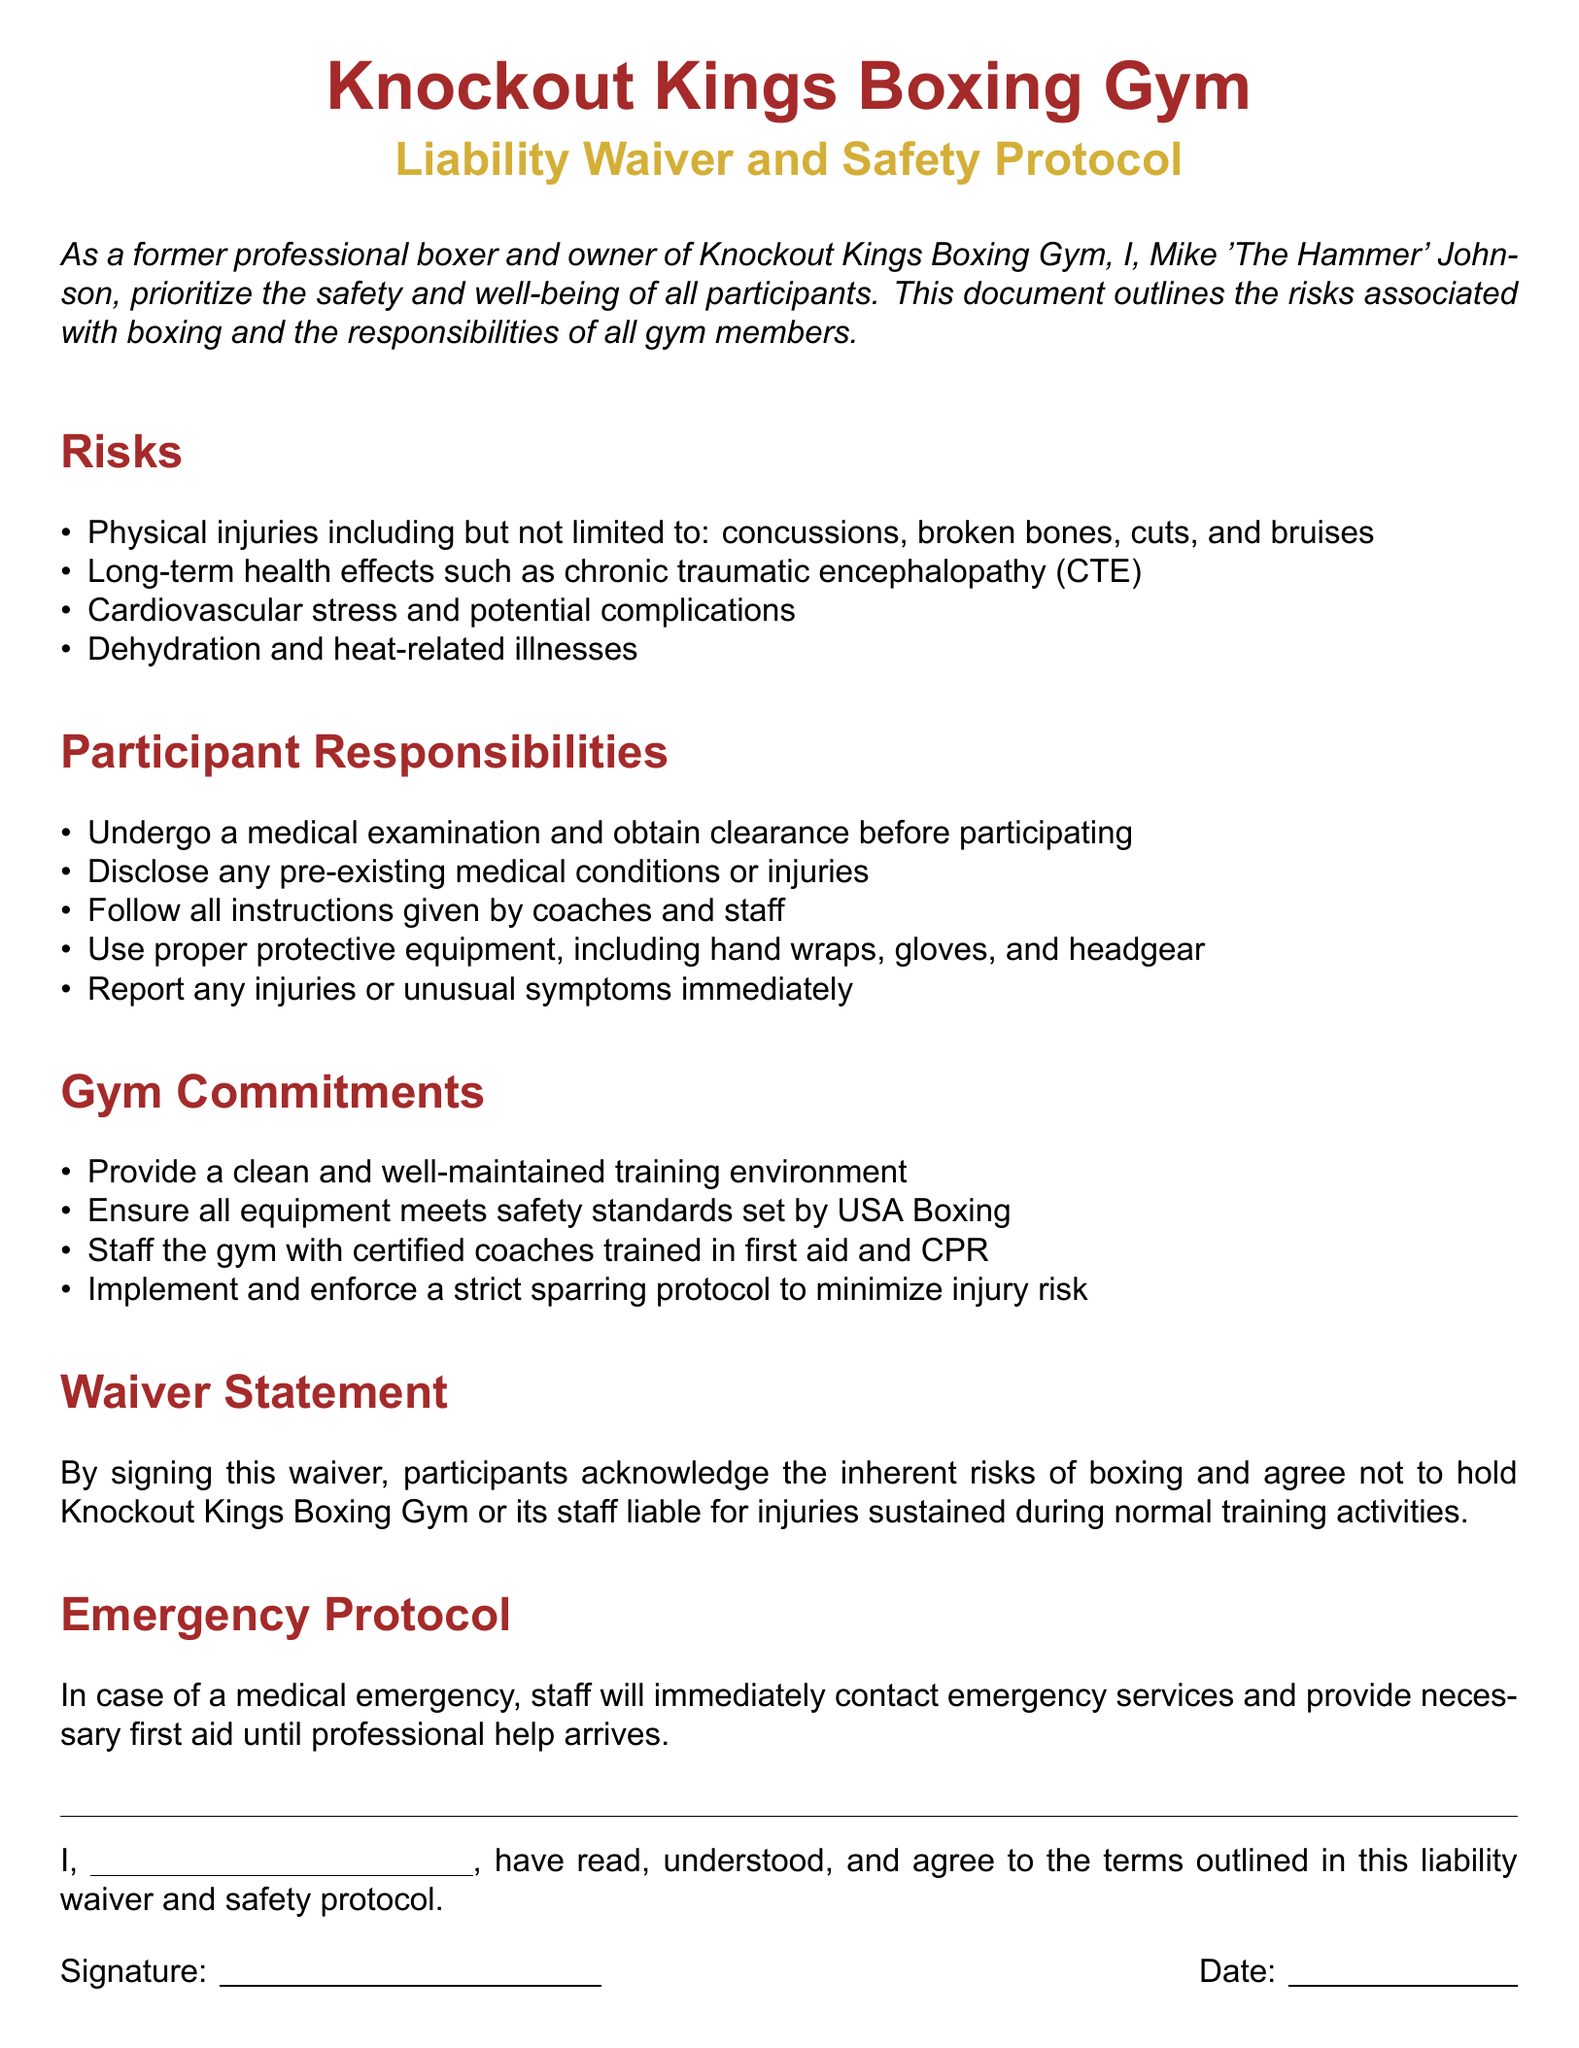What is the name of the gym? The name of the gym is stated prominently at the top of the document.
Answer: Knockout Kings Boxing Gym Who is the owner of the gym? The owner is mentioned in the introductory section of the document.
Answer: Mike 'The Hammer' Johnson What is one potential long-term health effect of boxing mentioned? A specific health effect is listed under the risks section of the document.
Answer: Chronic traumatic encephalopathy (CTE) What must participants use during training? The document specifies protective equipment that must be used by participants.
Answer: Hand wraps, gloves, and headgear What is the gym's commitment regarding emergency services? The gym's protocol in case of a medical emergency is explained in the emergency protocol section.
Answer: Staff will contact emergency services How many risks are listed in the document? The exact number of risks outlined in the risks section can be counted directly from the list.
Answer: Four What must participants disclose before participating? The participant responsibilities section mentions a specific requirement for participants regarding their health.
Answer: Pre-existing medical conditions or injuries What does signing the waiver indicate about the participants? The waiver statement conveys a specific acknowledgment from the participants.
Answer: Acknowledge the inherent risks of boxing What is the first commitment of the gym listed? The gym's commitments section starts with a statement about the training environment.
Answer: Provide a clean and well-maintained training environment 